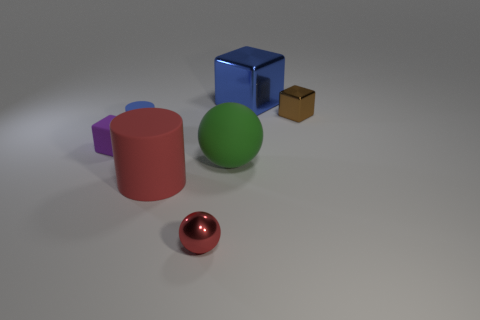Add 3 big yellow shiny cubes. How many objects exist? 10 Subtract all balls. How many objects are left? 5 Add 5 small blue cylinders. How many small blue cylinders are left? 6 Add 7 brown things. How many brown things exist? 8 Subtract 0 purple cylinders. How many objects are left? 7 Subtract all big balls. Subtract all big green things. How many objects are left? 5 